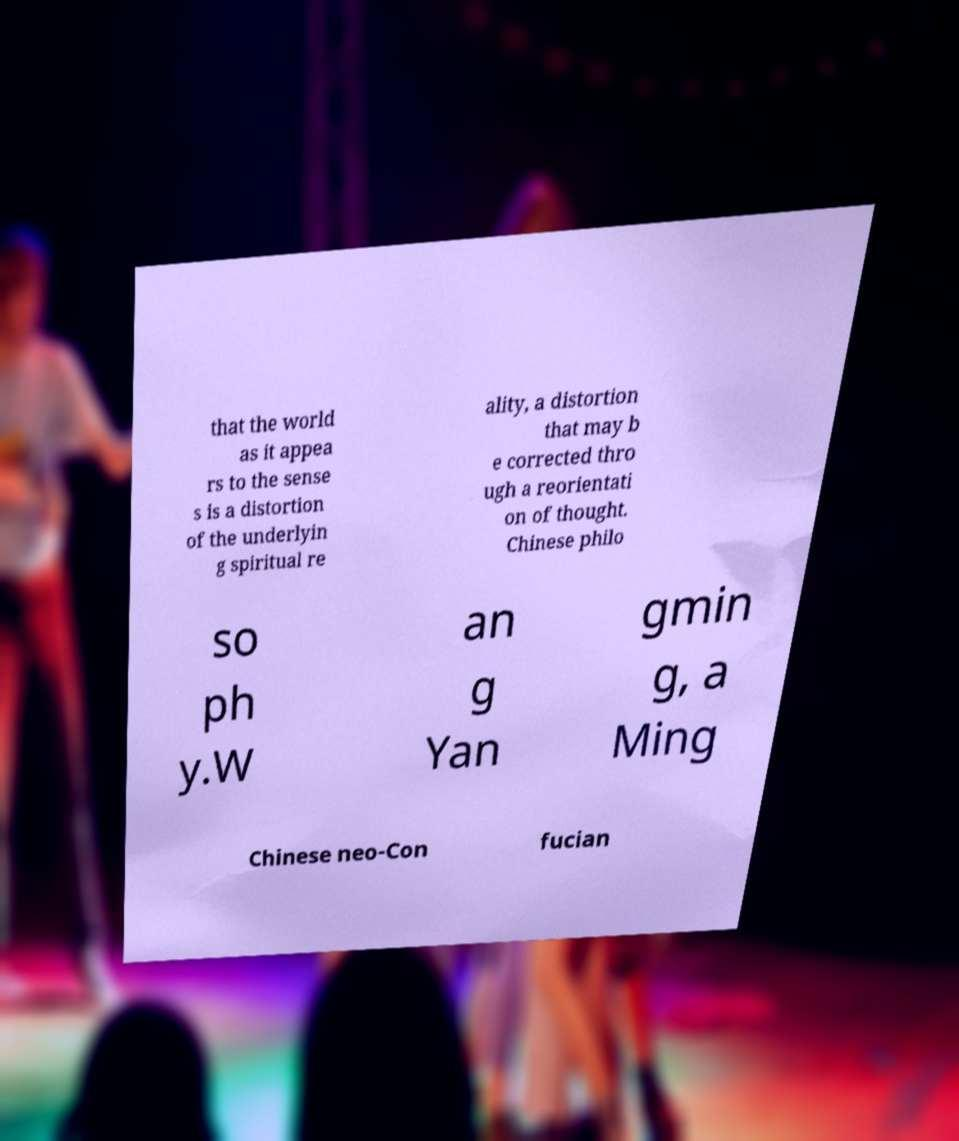Can you accurately transcribe the text from the provided image for me? that the world as it appea rs to the sense s is a distortion of the underlyin g spiritual re ality, a distortion that may b e corrected thro ugh a reorientati on of thought. Chinese philo so ph y.W an g Yan gmin g, a Ming Chinese neo-Con fucian 